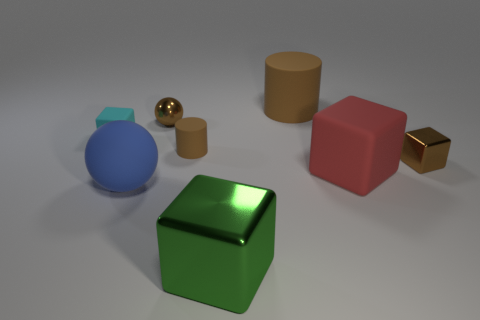Is there another large blue object that has the same shape as the large shiny thing?
Provide a succinct answer. No. Does the brown metal cube have the same size as the brown matte cylinder that is behind the tiny rubber cube?
Make the answer very short. No. What number of things are either big objects that are to the right of the small brown metallic sphere or things in front of the brown metallic block?
Keep it short and to the point. 4. Are there more brown metal spheres that are behind the large brown object than large green shiny cubes?
Ensure brevity in your answer.  No. What number of blue matte spheres have the same size as the shiny ball?
Your answer should be very brief. 0. Is the size of the cylinder that is left of the large metal thing the same as the matte cylinder that is behind the cyan rubber object?
Provide a succinct answer. No. There is a rubber cube that is on the right side of the big green metallic thing; what size is it?
Your response must be concise. Large. There is a brown metallic object that is to the left of the large object that is in front of the large blue rubber ball; what is its size?
Keep it short and to the point. Small. What is the material of the cylinder that is the same size as the brown block?
Your answer should be very brief. Rubber. There is a brown cube; are there any small brown matte cylinders behind it?
Make the answer very short. Yes. 